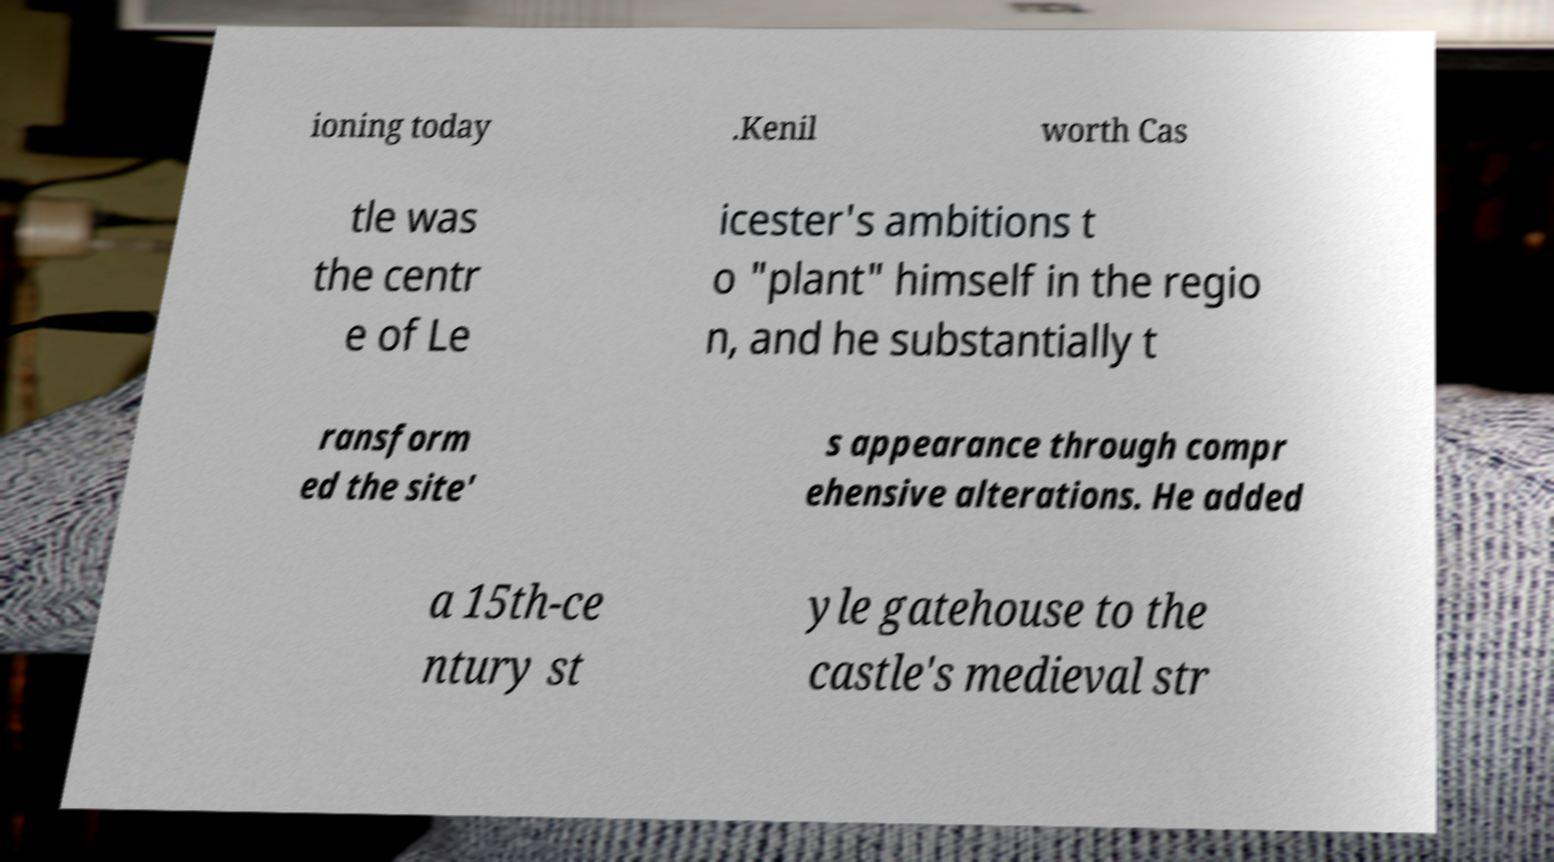Could you assist in decoding the text presented in this image and type it out clearly? ioning today .Kenil worth Cas tle was the centr e of Le icester's ambitions t o "plant" himself in the regio n, and he substantially t ransform ed the site' s appearance through compr ehensive alterations. He added a 15th-ce ntury st yle gatehouse to the castle's medieval str 